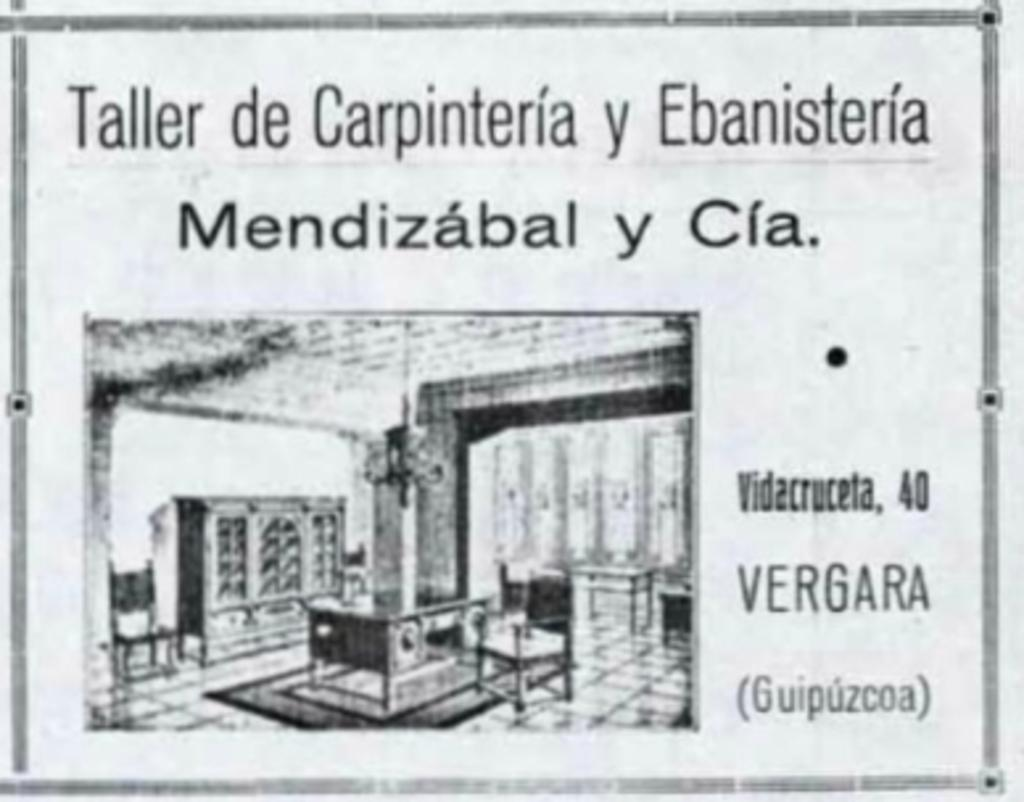What is present on the surface in the image? There is a paper in the image. What type of furniture can be seen in the image? There are tables and chairs in the image. What is the large, vertical object in the image? There is a cupboard in the image. How many worms are crawling on the paper in the image? There are no worms present in the image; it only features a paper, tables, chairs, and a cupboard. 